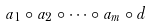Convert formula to latex. <formula><loc_0><loc_0><loc_500><loc_500>a _ { 1 } \circ a _ { 2 } \circ \dots \circ a _ { m } \circ d</formula> 